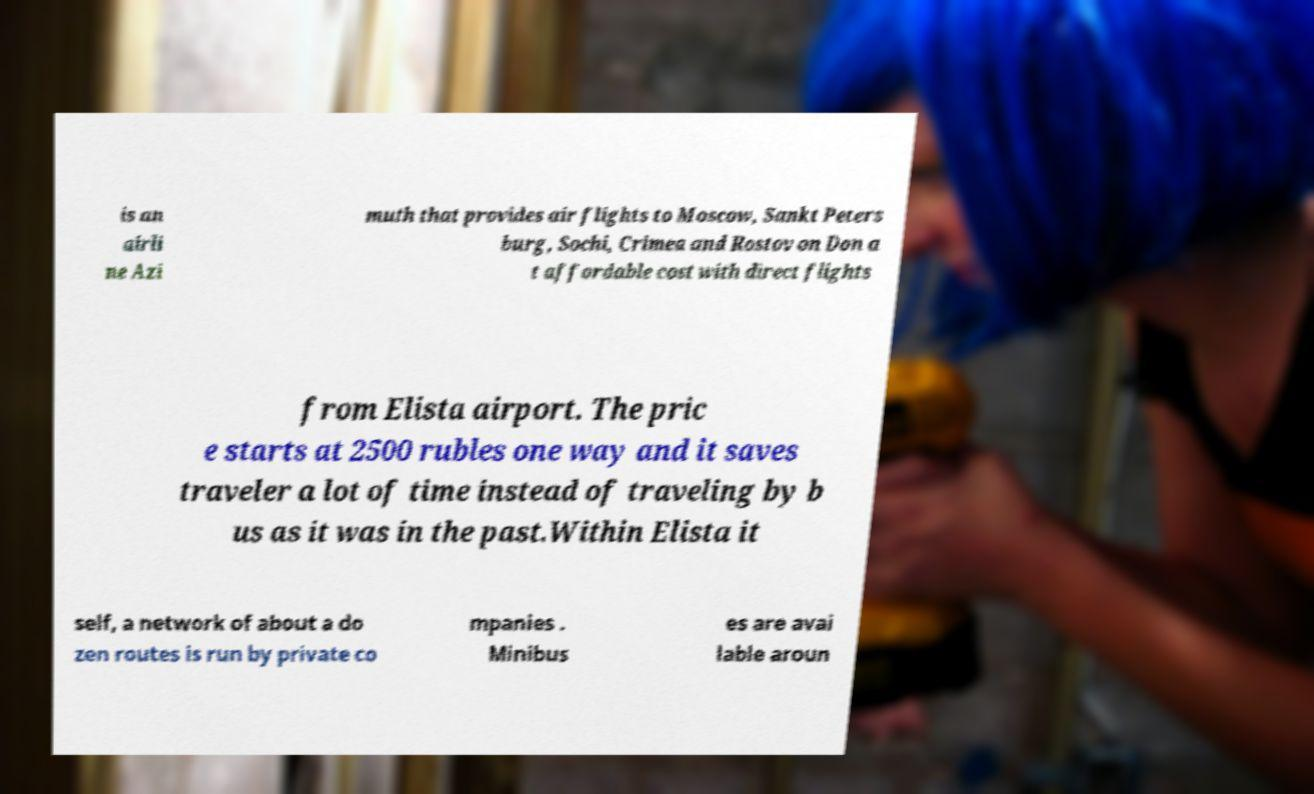Could you assist in decoding the text presented in this image and type it out clearly? is an airli ne Azi muth that provides air flights to Moscow, Sankt Peters burg, Sochi, Crimea and Rostov on Don a t affordable cost with direct flights from Elista airport. The pric e starts at 2500 rubles one way and it saves traveler a lot of time instead of traveling by b us as it was in the past.Within Elista it self, a network of about a do zen routes is run by private co mpanies . Minibus es are avai lable aroun 